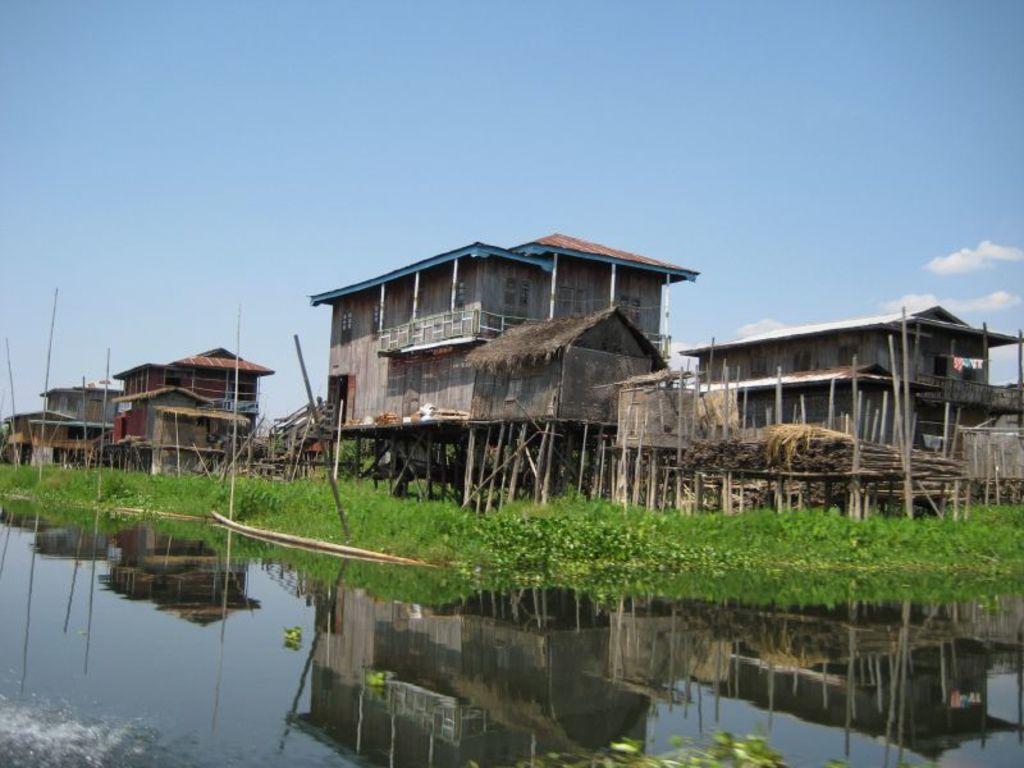What is one of the main elements in the image? There is water in the image. What else can be seen in the image besides water? There are plants and houses in the image. What is visible in the background of the image? There are clouds visible in the background of the image. Where is the pin located in the image? There is no pin present in the image. What type of linen can be seen draped over the plants in the image? There is no linen present in the image; it only features plants, water, houses, and clouds. 